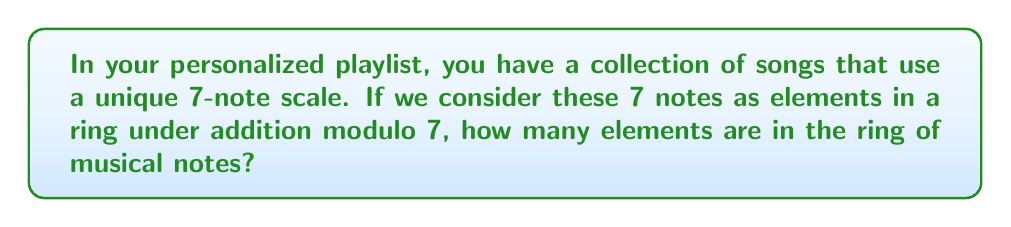Solve this math problem. To determine the number of elements in this ring of musical notes, we need to consider the properties of a ring and the given information:

1) The ring is based on a 7-note scale, which suggests that we are working with addition modulo 7.

2) In modular arithmetic, the number of elements in a ring is equal to the modulus. This is because each element in the ring corresponds to a residue class modulo the given number.

3) In this case, our modulus is 7, so we will have 7 distinct elements in the ring:

   $${0, 1, 2, 3, 4, 5, 6}$$

4) These elements represent the 7 notes in the scale, where each number corresponds to a specific note. For example:
   
   0 might represent the root note
   1 might represent the second note of the scale
   2 might represent the third note of the scale
   ...and so on.

5) Under addition modulo 7, these elements form a closed system. For example:

   $$5 + 4 \equiv 2 \pmod{7}$$

   This operation would be analogous to moving up the scale from the 5th note by 4 steps, which would land on the 2nd note of the next octave (hence, equivalent to the 2nd note in the original octave).

Therefore, the ring of musical notes based on this 7-note scale contains exactly 7 elements.
Answer: The ring contains 7 elements. 